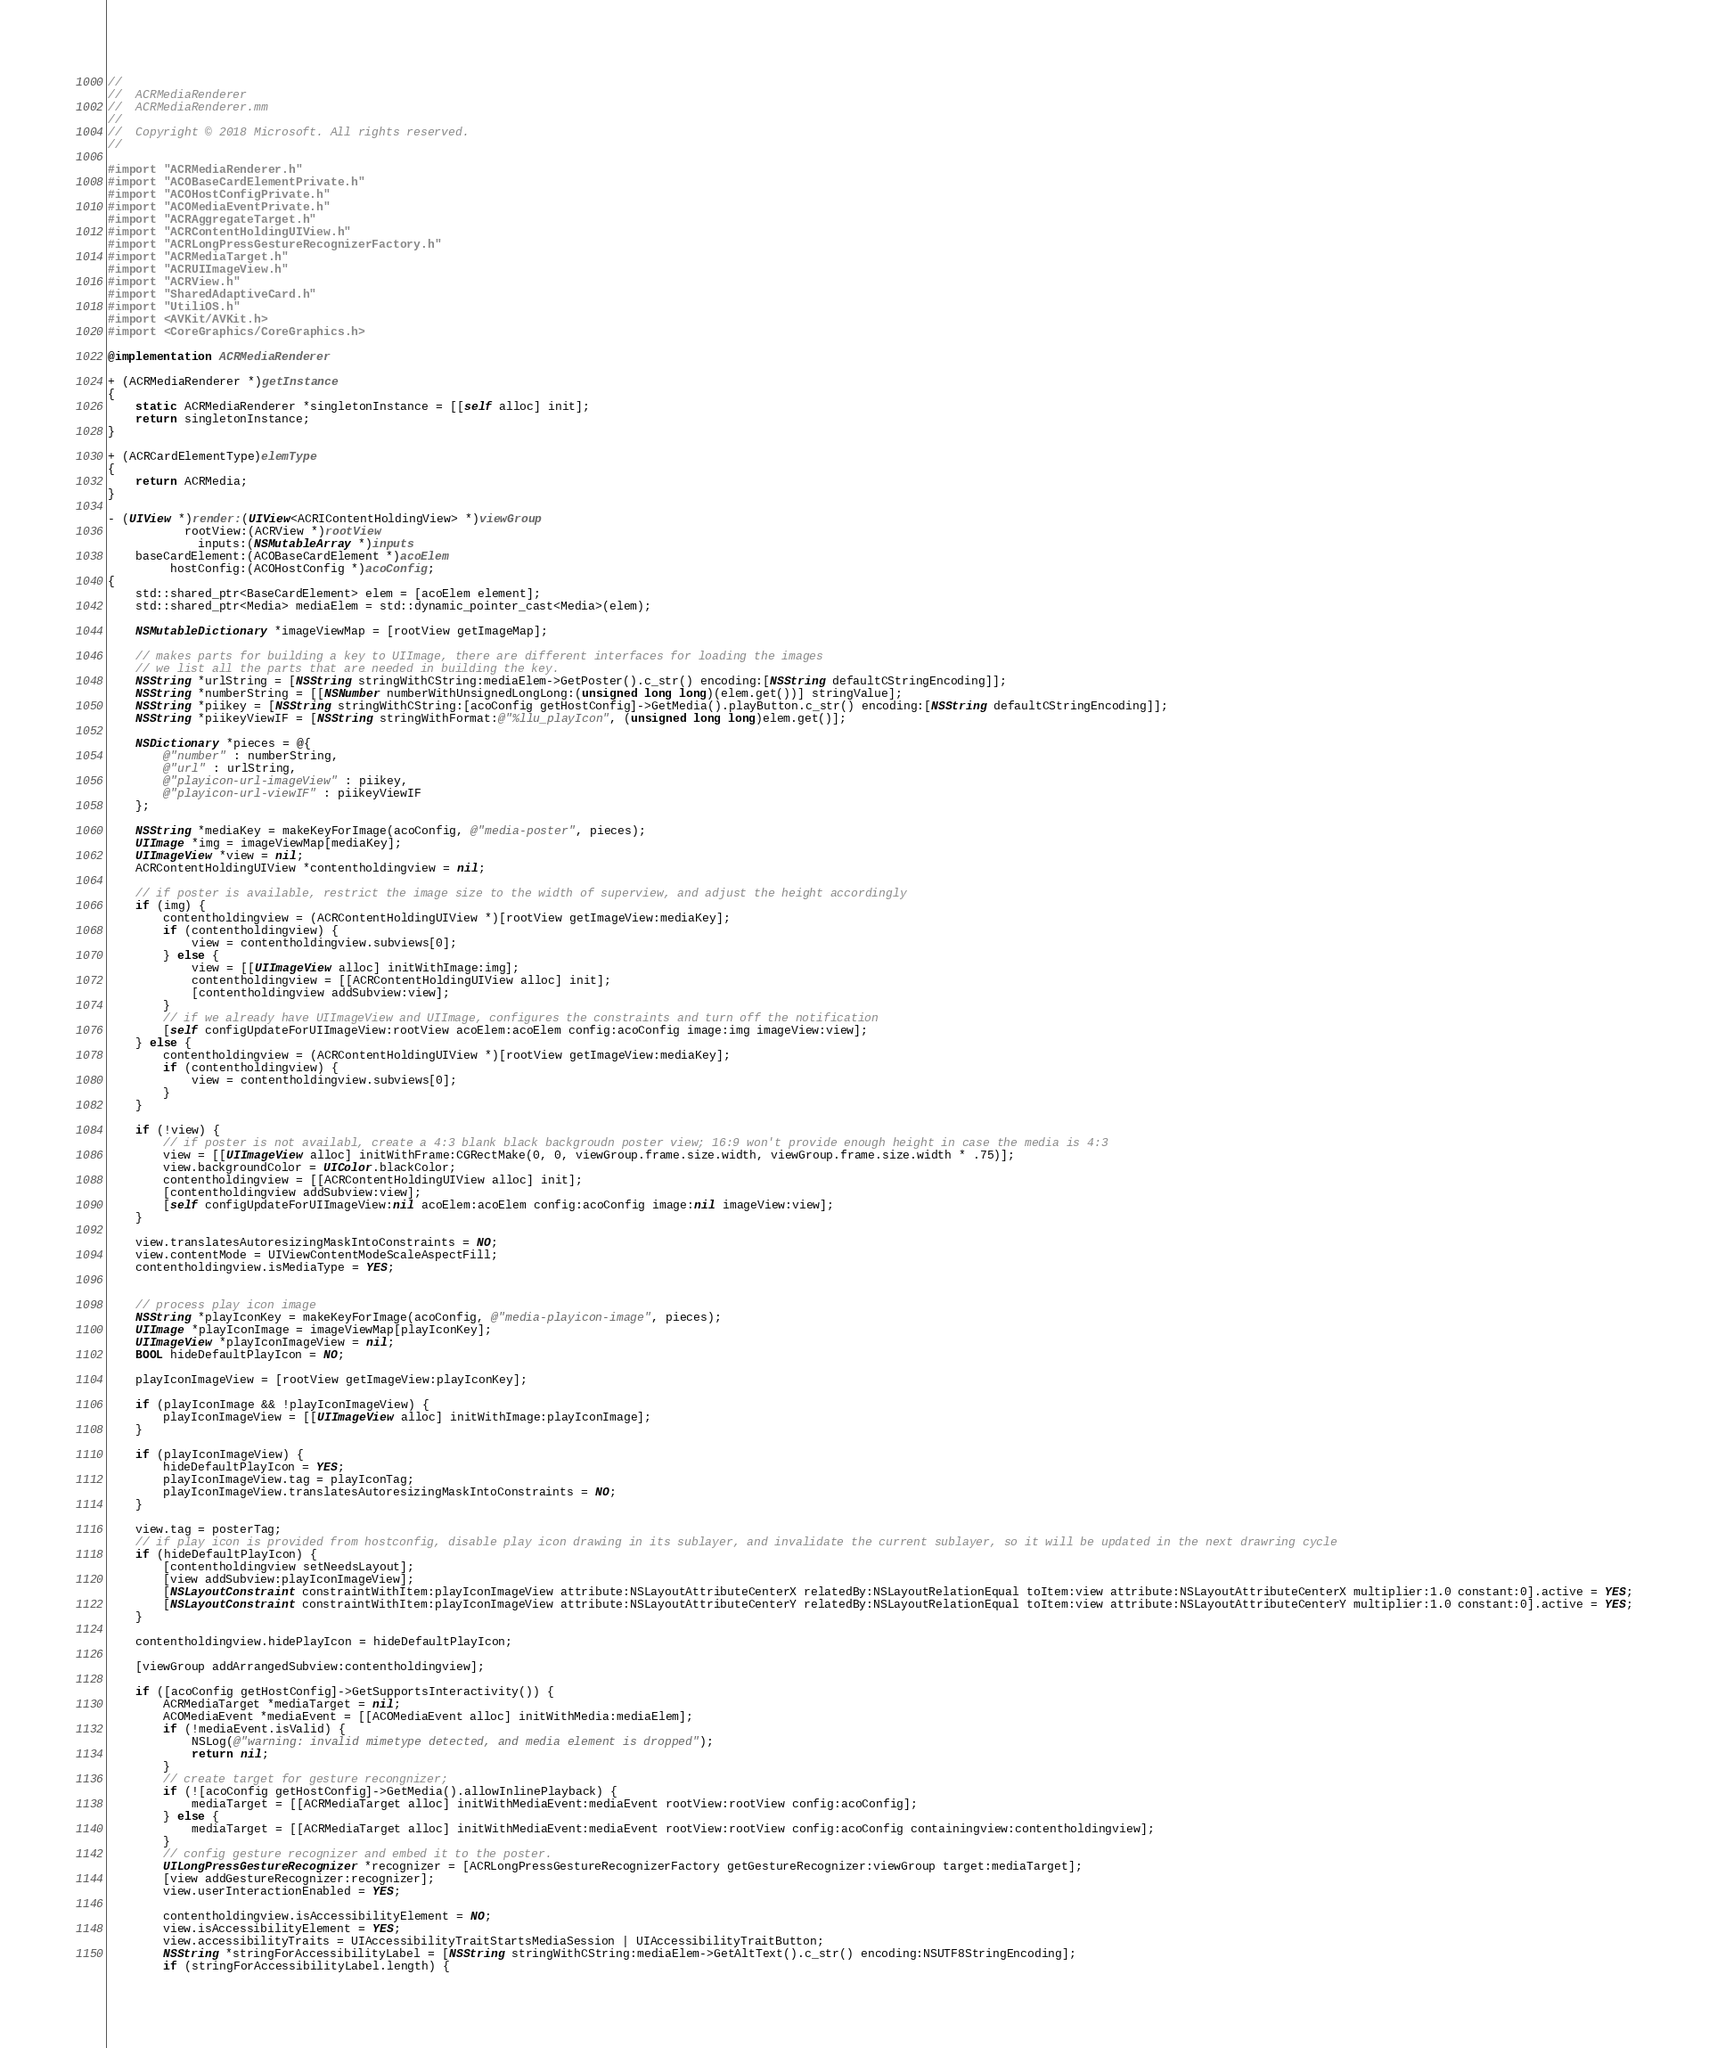Convert code to text. <code><loc_0><loc_0><loc_500><loc_500><_ObjectiveC_>//
//  ACRMediaRenderer
//  ACRMediaRenderer.mm
//
//  Copyright © 2018 Microsoft. All rights reserved.
//

#import "ACRMediaRenderer.h"
#import "ACOBaseCardElementPrivate.h"
#import "ACOHostConfigPrivate.h"
#import "ACOMediaEventPrivate.h"
#import "ACRAggregateTarget.h"
#import "ACRContentHoldingUIView.h"
#import "ACRLongPressGestureRecognizerFactory.h"
#import "ACRMediaTarget.h"
#import "ACRUIImageView.h"
#import "ACRView.h"
#import "SharedAdaptiveCard.h"
#import "UtiliOS.h"
#import <AVKit/AVKit.h>
#import <CoreGraphics/CoreGraphics.h>

@implementation ACRMediaRenderer

+ (ACRMediaRenderer *)getInstance
{
    static ACRMediaRenderer *singletonInstance = [[self alloc] init];
    return singletonInstance;
}

+ (ACRCardElementType)elemType
{
    return ACRMedia;
}

- (UIView *)render:(UIView<ACRIContentHoldingView> *)viewGroup
           rootView:(ACRView *)rootView
             inputs:(NSMutableArray *)inputs
    baseCardElement:(ACOBaseCardElement *)acoElem
         hostConfig:(ACOHostConfig *)acoConfig;
{
    std::shared_ptr<BaseCardElement> elem = [acoElem element];
    std::shared_ptr<Media> mediaElem = std::dynamic_pointer_cast<Media>(elem);

    NSMutableDictionary *imageViewMap = [rootView getImageMap];

    // makes parts for building a key to UIImage, there are different interfaces for loading the images
    // we list all the parts that are needed in building the key.
    NSString *urlString = [NSString stringWithCString:mediaElem->GetPoster().c_str() encoding:[NSString defaultCStringEncoding]];
    NSString *numberString = [[NSNumber numberWithUnsignedLongLong:(unsigned long long)(elem.get())] stringValue];
    NSString *piikey = [NSString stringWithCString:[acoConfig getHostConfig]->GetMedia().playButton.c_str() encoding:[NSString defaultCStringEncoding]];
    NSString *piikeyViewIF = [NSString stringWithFormat:@"%llu_playIcon", (unsigned long long)elem.get()];

    NSDictionary *pieces = @{
        @"number" : numberString,
        @"url" : urlString,
        @"playicon-url-imageView" : piikey,
        @"playicon-url-viewIF" : piikeyViewIF
    };

    NSString *mediaKey = makeKeyForImage(acoConfig, @"media-poster", pieces);
    UIImage *img = imageViewMap[mediaKey];
    UIImageView *view = nil;
    ACRContentHoldingUIView *contentholdingview = nil;

    // if poster is available, restrict the image size to the width of superview, and adjust the height accordingly
    if (img) {
        contentholdingview = (ACRContentHoldingUIView *)[rootView getImageView:mediaKey];
        if (contentholdingview) {
            view = contentholdingview.subviews[0];
        } else {
            view = [[UIImageView alloc] initWithImage:img];
            contentholdingview = [[ACRContentHoldingUIView alloc] init];
            [contentholdingview addSubview:view];
        }
        // if we already have UIImageView and UIImage, configures the constraints and turn off the notification
        [self configUpdateForUIImageView:rootView acoElem:acoElem config:acoConfig image:img imageView:view];
    } else {
        contentholdingview = (ACRContentHoldingUIView *)[rootView getImageView:mediaKey];
        if (contentholdingview) {
            view = contentholdingview.subviews[0];
        }
    }

    if (!view) {
        // if poster is not availabl, create a 4:3 blank black backgroudn poster view; 16:9 won't provide enough height in case the media is 4:3
        view = [[UIImageView alloc] initWithFrame:CGRectMake(0, 0, viewGroup.frame.size.width, viewGroup.frame.size.width * .75)];
        view.backgroundColor = UIColor.blackColor;
        contentholdingview = [[ACRContentHoldingUIView alloc] init];
        [contentholdingview addSubview:view];
        [self configUpdateForUIImageView:nil acoElem:acoElem config:acoConfig image:nil imageView:view];
    }

    view.translatesAutoresizingMaskIntoConstraints = NO;
    view.contentMode = UIViewContentModeScaleAspectFill;
    contentholdingview.isMediaType = YES;


    // process play icon image
    NSString *playIconKey = makeKeyForImage(acoConfig, @"media-playicon-image", pieces);
    UIImage *playIconImage = imageViewMap[playIconKey];
    UIImageView *playIconImageView = nil;
    BOOL hideDefaultPlayIcon = NO;

    playIconImageView = [rootView getImageView:playIconKey];

    if (playIconImage && !playIconImageView) {
        playIconImageView = [[UIImageView alloc] initWithImage:playIconImage];
    }

    if (playIconImageView) {
        hideDefaultPlayIcon = YES;
        playIconImageView.tag = playIconTag;
        playIconImageView.translatesAutoresizingMaskIntoConstraints = NO;
    }

    view.tag = posterTag;
    // if play icon is provided from hostconfig, disable play icon drawing in its sublayer, and invalidate the current sublayer, so it will be updated in the next drawring cycle
    if (hideDefaultPlayIcon) {
        [contentholdingview setNeedsLayout];
        [view addSubview:playIconImageView];
        [NSLayoutConstraint constraintWithItem:playIconImageView attribute:NSLayoutAttributeCenterX relatedBy:NSLayoutRelationEqual toItem:view attribute:NSLayoutAttributeCenterX multiplier:1.0 constant:0].active = YES;
        [NSLayoutConstraint constraintWithItem:playIconImageView attribute:NSLayoutAttributeCenterY relatedBy:NSLayoutRelationEqual toItem:view attribute:NSLayoutAttributeCenterY multiplier:1.0 constant:0].active = YES;
    }

    contentholdingview.hidePlayIcon = hideDefaultPlayIcon;

    [viewGroup addArrangedSubview:contentholdingview];

    if ([acoConfig getHostConfig]->GetSupportsInteractivity()) {
        ACRMediaTarget *mediaTarget = nil;
        ACOMediaEvent *mediaEvent = [[ACOMediaEvent alloc] initWithMedia:mediaElem];
        if (!mediaEvent.isValid) {
            NSLog(@"warning: invalid mimetype detected, and media element is dropped");
            return nil;
        }
        // create target for gesture recongnizer;
        if (![acoConfig getHostConfig]->GetMedia().allowInlinePlayback) {
            mediaTarget = [[ACRMediaTarget alloc] initWithMediaEvent:mediaEvent rootView:rootView config:acoConfig];
        } else {
            mediaTarget = [[ACRMediaTarget alloc] initWithMediaEvent:mediaEvent rootView:rootView config:acoConfig containingview:contentholdingview];
        }
        // config gesture recognizer and embed it to the poster.
        UILongPressGestureRecognizer *recognizer = [ACRLongPressGestureRecognizerFactory getGestureRecognizer:viewGroup target:mediaTarget];
        [view addGestureRecognizer:recognizer];
        view.userInteractionEnabled = YES;

        contentholdingview.isAccessibilityElement = NO;
        view.isAccessibilityElement = YES;
        view.accessibilityTraits = UIAccessibilityTraitStartsMediaSession | UIAccessibilityTraitButton;
        NSString *stringForAccessibilityLabel = [NSString stringWithCString:mediaElem->GetAltText().c_str() encoding:NSUTF8StringEncoding];
        if (stringForAccessibilityLabel.length) {</code> 